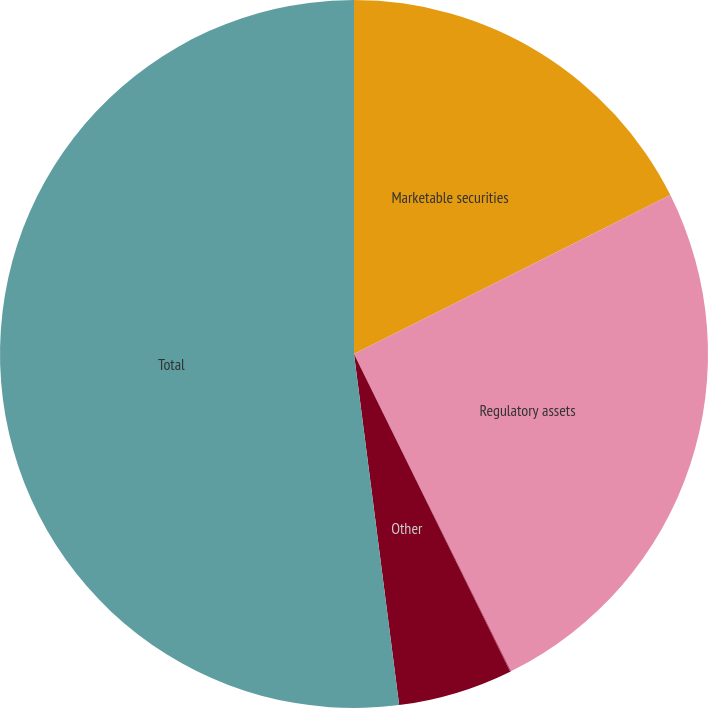Convert chart to OTSL. <chart><loc_0><loc_0><loc_500><loc_500><pie_chart><fcel>Marketable securities<fcel>Regulatory assets<fcel>Assets from risk management<fcel>Other<fcel>Total<nl><fcel>17.59%<fcel>25.09%<fcel>0.04%<fcel>5.24%<fcel>52.03%<nl></chart> 